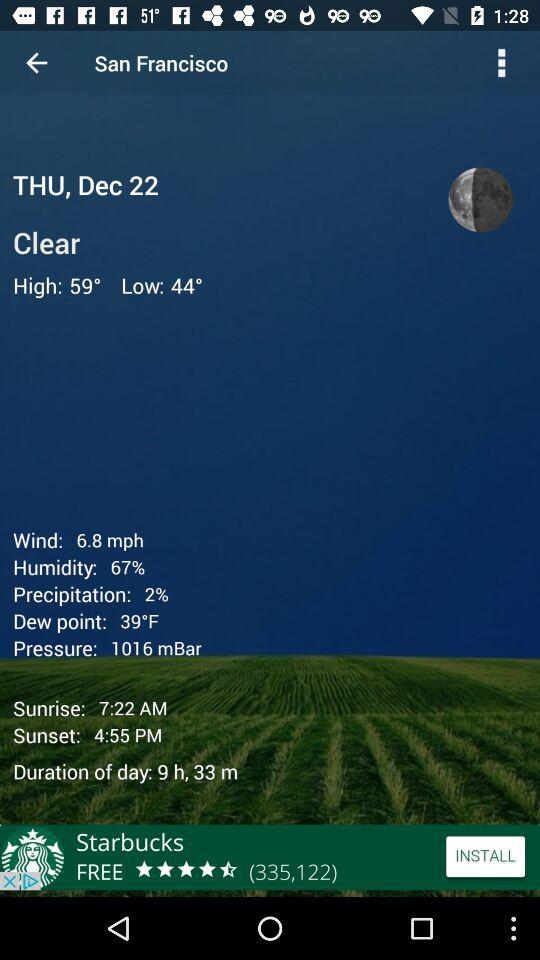What is the duration of the day? The duration of the day is 9 hours 33 minutes. 